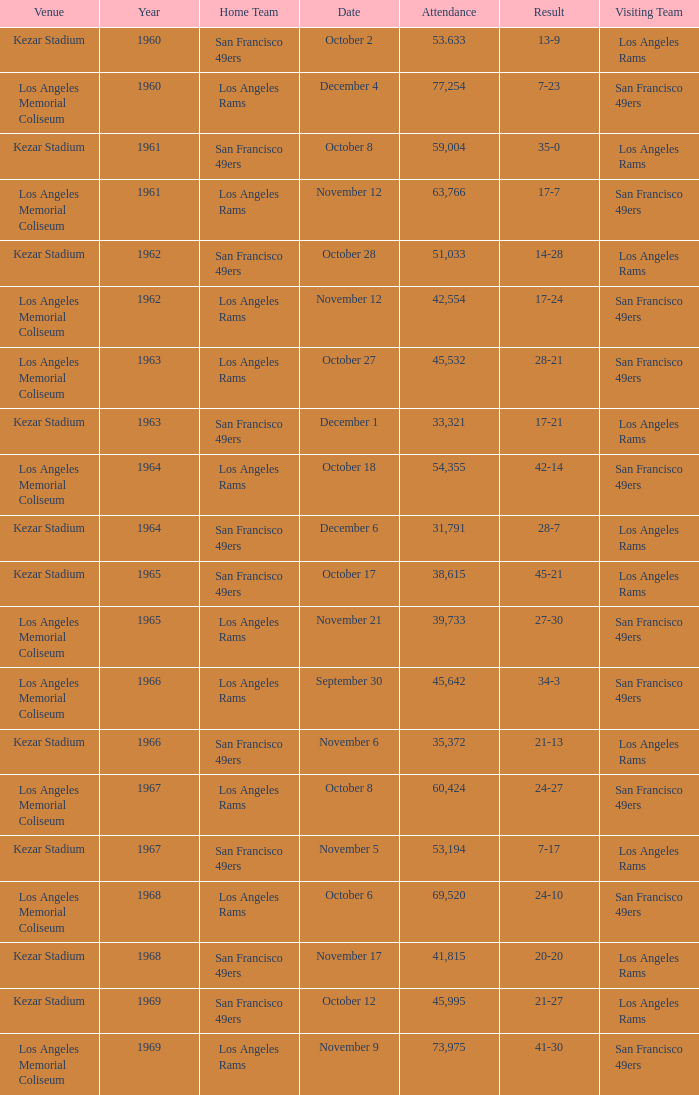Who is the home team when the san francisco 49ers are visiting with a result of 42-14? Los Angeles Rams. 